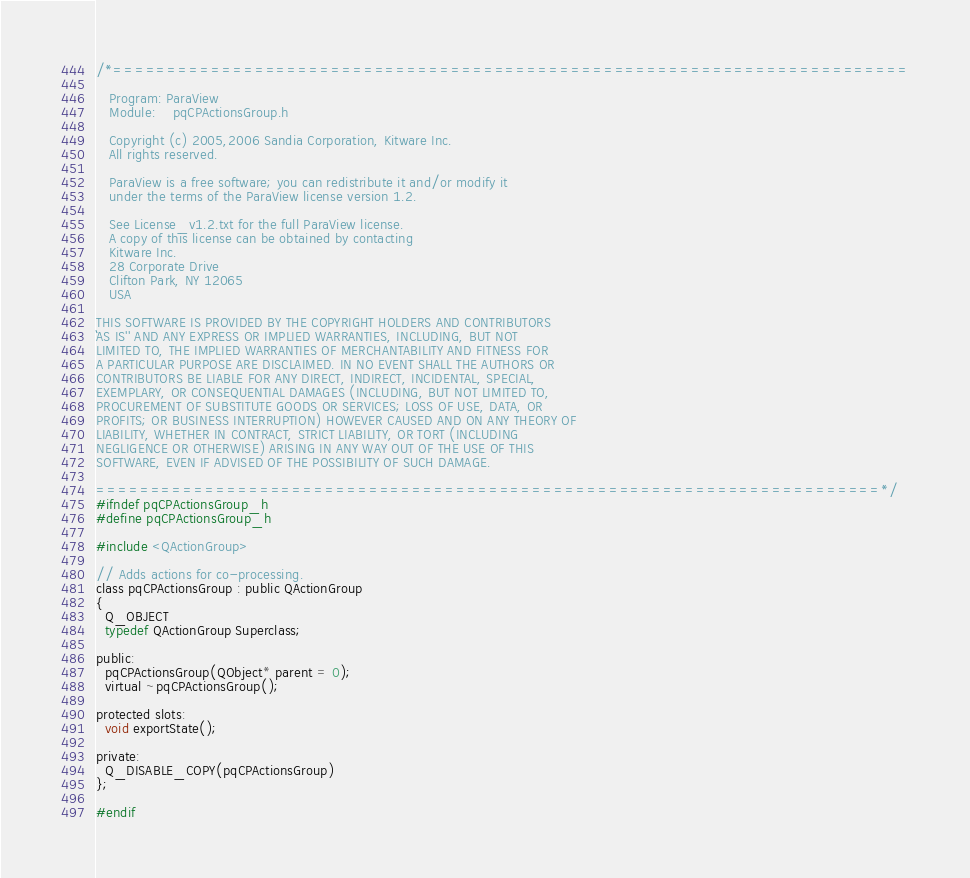Convert code to text. <code><loc_0><loc_0><loc_500><loc_500><_C_>/*=========================================================================

   Program: ParaView
   Module:    pqCPActionsGroup.h

   Copyright (c) 2005,2006 Sandia Corporation, Kitware Inc.
   All rights reserved.

   ParaView is a free software; you can redistribute it and/or modify it
   under the terms of the ParaView license version 1.2.

   See License_v1.2.txt for the full ParaView license.
   A copy of this license can be obtained by contacting
   Kitware Inc.
   28 Corporate Drive
   Clifton Park, NY 12065
   USA

THIS SOFTWARE IS PROVIDED BY THE COPYRIGHT HOLDERS AND CONTRIBUTORS
``AS IS'' AND ANY EXPRESS OR IMPLIED WARRANTIES, INCLUDING, BUT NOT
LIMITED TO, THE IMPLIED WARRANTIES OF MERCHANTABILITY AND FITNESS FOR
A PARTICULAR PURPOSE ARE DISCLAIMED. IN NO EVENT SHALL THE AUTHORS OR
CONTRIBUTORS BE LIABLE FOR ANY DIRECT, INDIRECT, INCIDENTAL, SPECIAL,
EXEMPLARY, OR CONSEQUENTIAL DAMAGES (INCLUDING, BUT NOT LIMITED TO,
PROCUREMENT OF SUBSTITUTE GOODS OR SERVICES; LOSS OF USE, DATA, OR
PROFITS; OR BUSINESS INTERRUPTION) HOWEVER CAUSED AND ON ANY THEORY OF
LIABILITY, WHETHER IN CONTRACT, STRICT LIABILITY, OR TORT (INCLUDING
NEGLIGENCE OR OTHERWISE) ARISING IN ANY WAY OUT OF THE USE OF THIS
SOFTWARE, EVEN IF ADVISED OF THE POSSIBILITY OF SUCH DAMAGE.

========================================================================*/
#ifndef pqCPActionsGroup_h
#define pqCPActionsGroup_h

#include <QActionGroup>

// Adds actions for co-processing.
class pqCPActionsGroup : public QActionGroup
{
  Q_OBJECT
  typedef QActionGroup Superclass;

public:
  pqCPActionsGroup(QObject* parent = 0);
  virtual ~pqCPActionsGroup();

protected slots:
  void exportState();

private:
  Q_DISABLE_COPY(pqCPActionsGroup)
};

#endif
</code> 